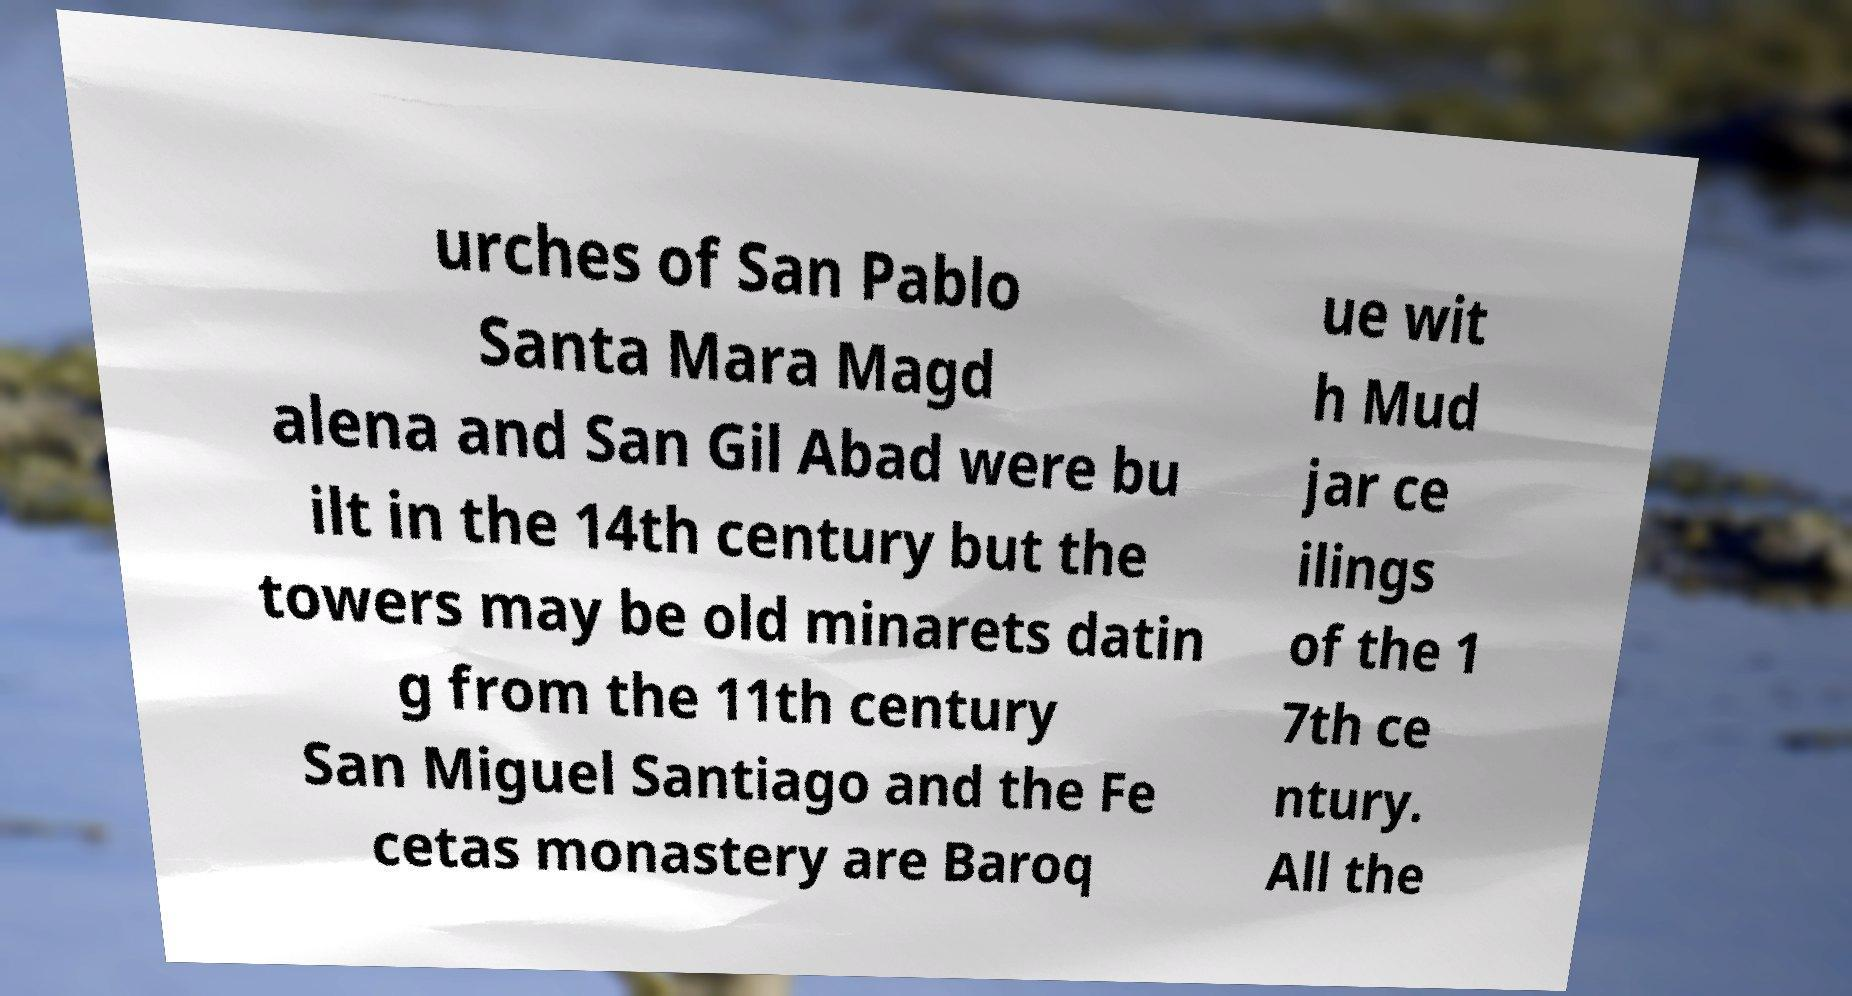There's text embedded in this image that I need extracted. Can you transcribe it verbatim? urches of San Pablo Santa Mara Magd alena and San Gil Abad were bu ilt in the 14th century but the towers may be old minarets datin g from the 11th century San Miguel Santiago and the Fe cetas monastery are Baroq ue wit h Mud jar ce ilings of the 1 7th ce ntury. All the 